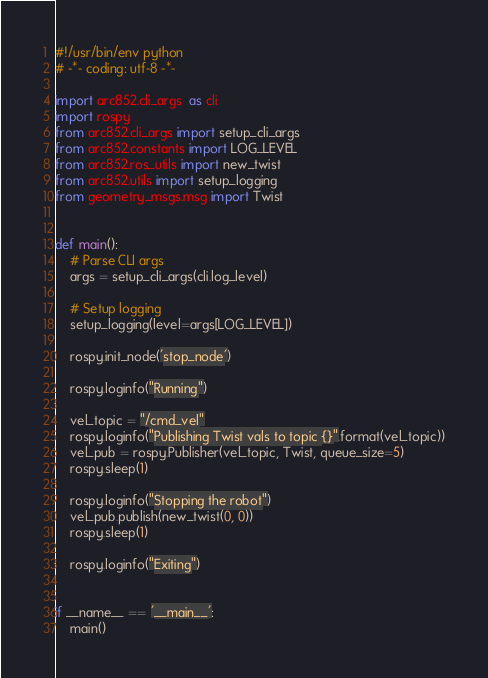<code> <loc_0><loc_0><loc_500><loc_500><_Python_>#!/usr/bin/env python
# -*- coding: utf-8 -*-

import arc852.cli_args  as cli
import rospy
from arc852.cli_args import setup_cli_args
from arc852.constants import LOG_LEVEL
from arc852.ros_utils import new_twist
from arc852.utils import setup_logging
from geometry_msgs.msg import Twist


def main():
    # Parse CLI args
    args = setup_cli_args(cli.log_level)

    # Setup logging
    setup_logging(level=args[LOG_LEVEL])

    rospy.init_node('stop_node')

    rospy.loginfo("Running")

    vel_topic = "/cmd_vel"
    rospy.loginfo("Publishing Twist vals to topic {}".format(vel_topic))
    vel_pub = rospy.Publisher(vel_topic, Twist, queue_size=5)
    rospy.sleep(1)

    rospy.loginfo("Stopping the robot")
    vel_pub.publish(new_twist(0, 0))
    rospy.sleep(1)

    rospy.loginfo("Exiting")


if __name__ == '__main__':
    main()
</code> 